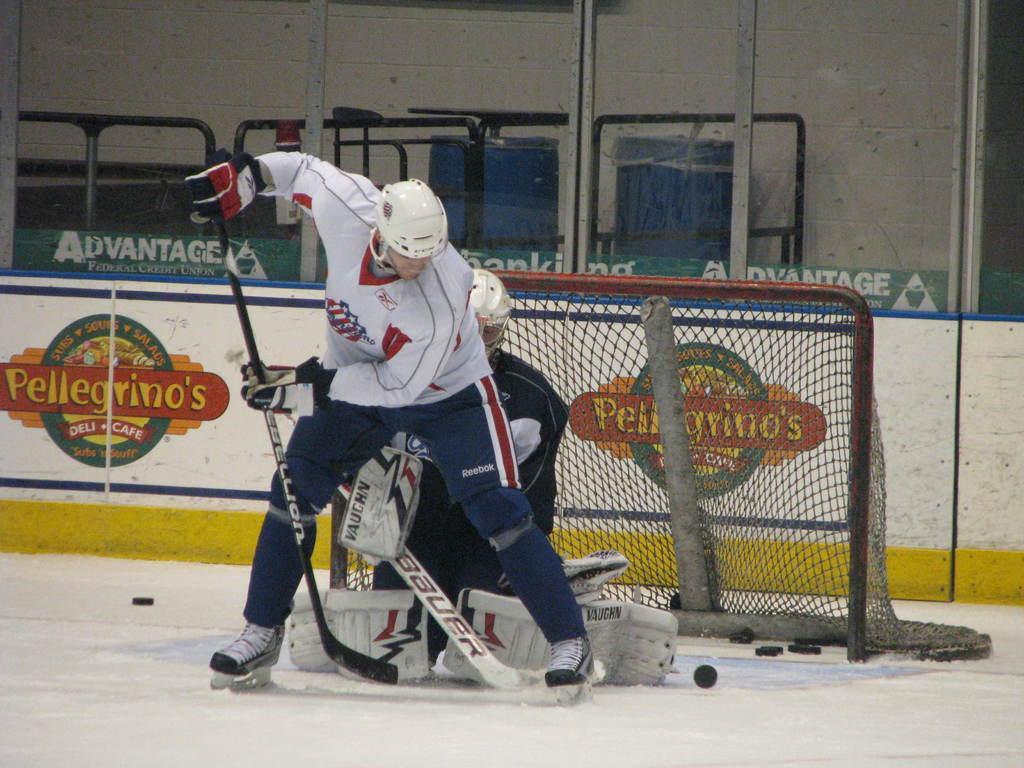In one or two sentences, can you explain what this image depicts? In the center of the image we can see two persons are playing ice hockey and they are holding hockey sticks. And we can see they are wearing helmets. In the background there is a wall, banners with some text, one goal post and a few other objects. 